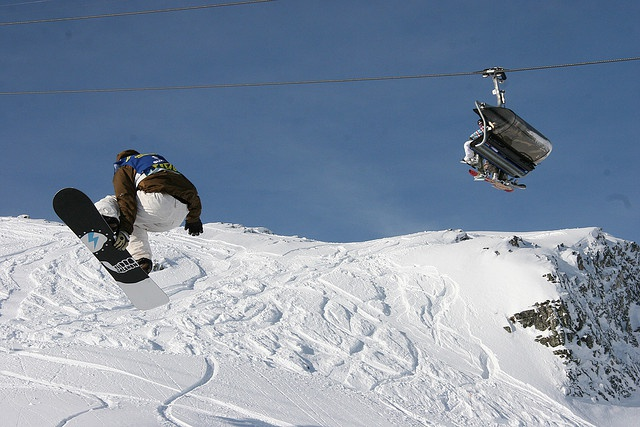Describe the objects in this image and their specific colors. I can see people in blue, black, darkgray, lightgray, and gray tones, snowboard in blue, black, darkgray, lightgray, and gray tones, people in blue, lightgray, darkgray, gray, and black tones, people in blue, black, gray, and darkgray tones, and snowboard in blue, gray, and maroon tones in this image. 